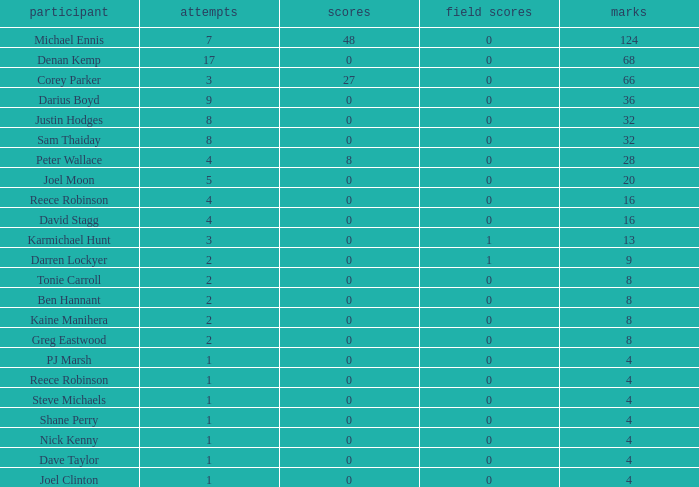How many goals did the player with less than 4 points have? 0.0. 